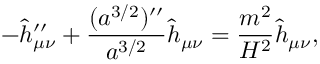Convert formula to latex. <formula><loc_0><loc_0><loc_500><loc_500>- \hat { h } _ { \mu \nu } ^ { \prime \prime } + { \frac { ( a ^ { 3 / 2 } ) ^ { \prime \prime } } { a ^ { 3 / 2 } } } \hat { h } _ { \mu \nu } = { \frac { m ^ { 2 } } { H ^ { 2 } } } \hat { h } _ { \mu \nu } ,</formula> 